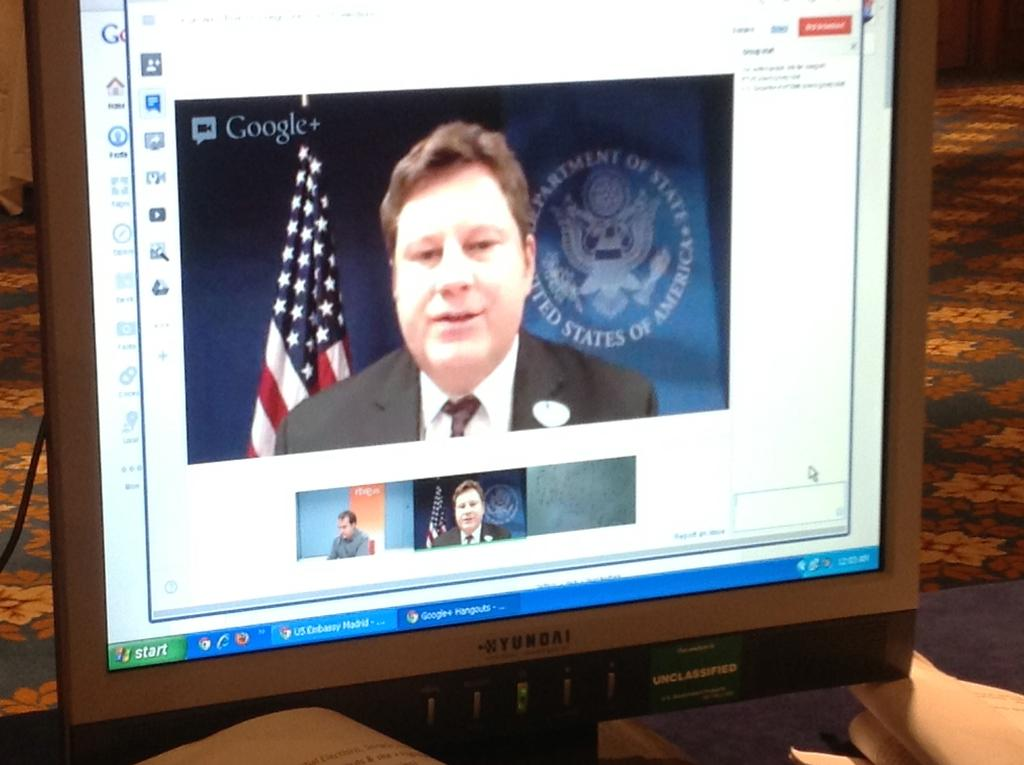<image>
Relay a brief, clear account of the picture shown. Yundai computer shows a video of a man talking 